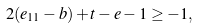Convert formula to latex. <formula><loc_0><loc_0><loc_500><loc_500>2 ( e _ { 1 1 } - b ) + t - e - 1 \geq - 1 ,</formula> 